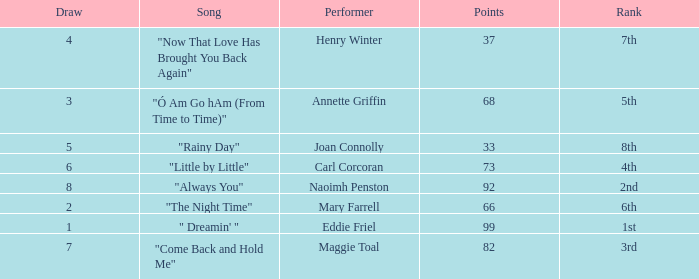Which song has more than 66 points, a draw greater than 3, and is ranked 3rd? "Come Back and Hold Me". 